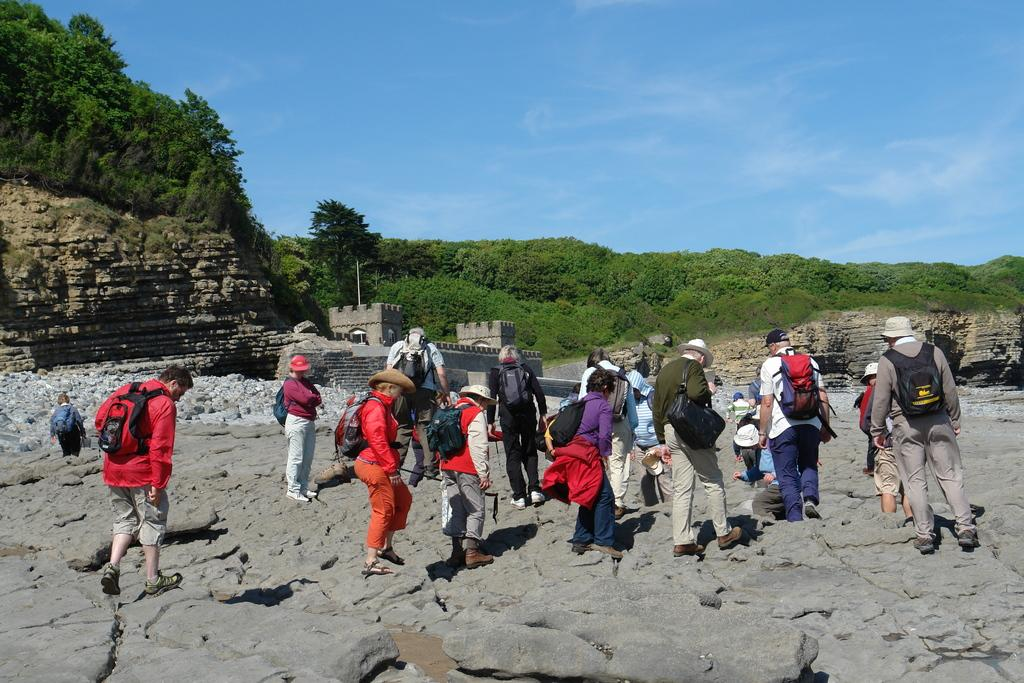What are the people in the foreground of the picture doing? The people in the foreground of the picture are walking. What can be seen in the center of the picture? There are trees and a fort in the center of the picture. What is the terrain like in the center of the picture? There is a hill in the center of the picture. How would you describe the weather in the picture? The sky is sunny in the picture. What type of driving activity is taking place in the picture? There is no driving activity present in the picture; people are walking. What kind of wall can be seen surrounding the fort in the picture? There is no wall surrounding the fort in the picture; only the fort itself is visible. 